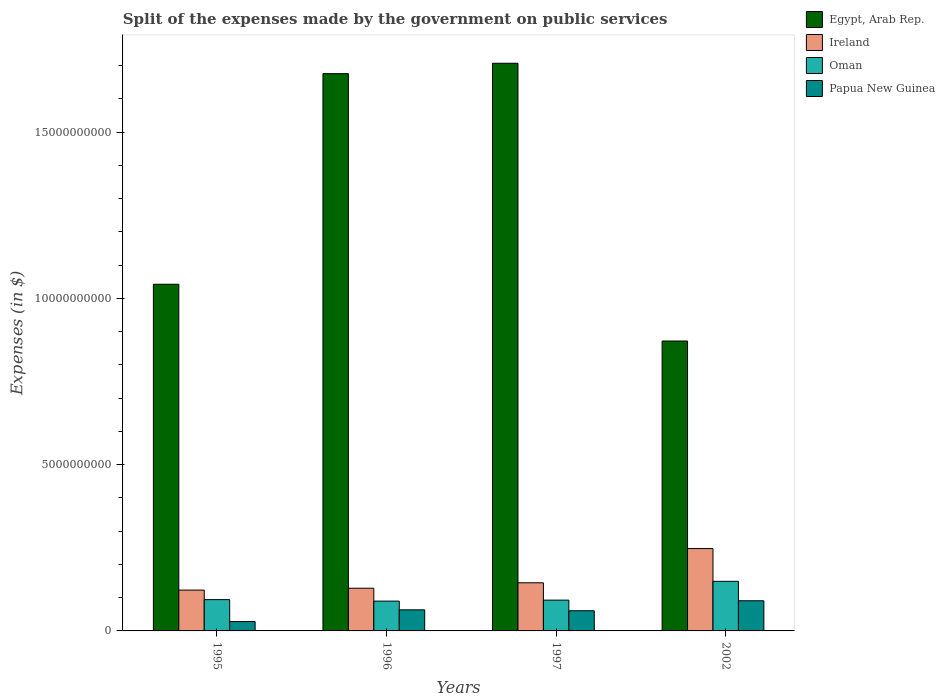How many different coloured bars are there?
Ensure brevity in your answer.  4. What is the label of the 4th group of bars from the left?
Offer a terse response. 2002. What is the expenses made by the government on public services in Ireland in 2002?
Your answer should be very brief. 2.48e+09. Across all years, what is the maximum expenses made by the government on public services in Egypt, Arab Rep.?
Make the answer very short. 1.71e+1. Across all years, what is the minimum expenses made by the government on public services in Ireland?
Provide a succinct answer. 1.23e+09. What is the total expenses made by the government on public services in Egypt, Arab Rep. in the graph?
Your response must be concise. 5.30e+1. What is the difference between the expenses made by the government on public services in Papua New Guinea in 1995 and that in 2002?
Ensure brevity in your answer.  -6.25e+08. What is the difference between the expenses made by the government on public services in Ireland in 1997 and the expenses made by the government on public services in Papua New Guinea in 2002?
Ensure brevity in your answer.  5.40e+08. What is the average expenses made by the government on public services in Oman per year?
Provide a succinct answer. 1.06e+09. In the year 1997, what is the difference between the expenses made by the government on public services in Ireland and expenses made by the government on public services in Egypt, Arab Rep.?
Provide a short and direct response. -1.56e+1. In how many years, is the expenses made by the government on public services in Oman greater than 12000000000 $?
Make the answer very short. 0. What is the ratio of the expenses made by the government on public services in Egypt, Arab Rep. in 1995 to that in 2002?
Offer a very short reply. 1.2. Is the difference between the expenses made by the government on public services in Ireland in 1995 and 1996 greater than the difference between the expenses made by the government on public services in Egypt, Arab Rep. in 1995 and 1996?
Your answer should be very brief. Yes. What is the difference between the highest and the second highest expenses made by the government on public services in Egypt, Arab Rep.?
Offer a terse response. 3.12e+08. What is the difference between the highest and the lowest expenses made by the government on public services in Ireland?
Ensure brevity in your answer.  1.25e+09. Is it the case that in every year, the sum of the expenses made by the government on public services in Papua New Guinea and expenses made by the government on public services in Egypt, Arab Rep. is greater than the sum of expenses made by the government on public services in Ireland and expenses made by the government on public services in Oman?
Ensure brevity in your answer.  No. What does the 4th bar from the left in 2002 represents?
Ensure brevity in your answer.  Papua New Guinea. What does the 1st bar from the right in 1996 represents?
Keep it short and to the point. Papua New Guinea. Is it the case that in every year, the sum of the expenses made by the government on public services in Papua New Guinea and expenses made by the government on public services in Oman is greater than the expenses made by the government on public services in Egypt, Arab Rep.?
Make the answer very short. No. Are the values on the major ticks of Y-axis written in scientific E-notation?
Give a very brief answer. No. Does the graph contain grids?
Ensure brevity in your answer.  No. Where does the legend appear in the graph?
Provide a short and direct response. Top right. How many legend labels are there?
Your answer should be very brief. 4. How are the legend labels stacked?
Your answer should be compact. Vertical. What is the title of the graph?
Ensure brevity in your answer.  Split of the expenses made by the government on public services. Does "Middle East & North Africa (developing only)" appear as one of the legend labels in the graph?
Your answer should be compact. No. What is the label or title of the X-axis?
Your response must be concise. Years. What is the label or title of the Y-axis?
Your response must be concise. Expenses (in $). What is the Expenses (in $) in Egypt, Arab Rep. in 1995?
Give a very brief answer. 1.04e+1. What is the Expenses (in $) of Ireland in 1995?
Your answer should be very brief. 1.23e+09. What is the Expenses (in $) in Oman in 1995?
Ensure brevity in your answer.  9.41e+08. What is the Expenses (in $) in Papua New Guinea in 1995?
Provide a succinct answer. 2.82e+08. What is the Expenses (in $) of Egypt, Arab Rep. in 1996?
Offer a very short reply. 1.68e+1. What is the Expenses (in $) in Ireland in 1996?
Keep it short and to the point. 1.28e+09. What is the Expenses (in $) in Oman in 1996?
Provide a short and direct response. 8.96e+08. What is the Expenses (in $) of Papua New Guinea in 1996?
Your answer should be compact. 6.34e+08. What is the Expenses (in $) of Egypt, Arab Rep. in 1997?
Your answer should be very brief. 1.71e+1. What is the Expenses (in $) in Ireland in 1997?
Offer a terse response. 1.45e+09. What is the Expenses (in $) in Oman in 1997?
Make the answer very short. 9.26e+08. What is the Expenses (in $) of Papua New Guinea in 1997?
Provide a short and direct response. 6.06e+08. What is the Expenses (in $) in Egypt, Arab Rep. in 2002?
Offer a terse response. 8.72e+09. What is the Expenses (in $) in Ireland in 2002?
Offer a very short reply. 2.48e+09. What is the Expenses (in $) of Oman in 2002?
Offer a terse response. 1.49e+09. What is the Expenses (in $) of Papua New Guinea in 2002?
Offer a terse response. 9.07e+08. Across all years, what is the maximum Expenses (in $) in Egypt, Arab Rep.?
Offer a very short reply. 1.71e+1. Across all years, what is the maximum Expenses (in $) of Ireland?
Offer a very short reply. 2.48e+09. Across all years, what is the maximum Expenses (in $) of Oman?
Provide a succinct answer. 1.49e+09. Across all years, what is the maximum Expenses (in $) in Papua New Guinea?
Give a very brief answer. 9.07e+08. Across all years, what is the minimum Expenses (in $) of Egypt, Arab Rep.?
Offer a terse response. 8.72e+09. Across all years, what is the minimum Expenses (in $) of Ireland?
Your answer should be compact. 1.23e+09. Across all years, what is the minimum Expenses (in $) in Oman?
Your response must be concise. 8.96e+08. Across all years, what is the minimum Expenses (in $) in Papua New Guinea?
Ensure brevity in your answer.  2.82e+08. What is the total Expenses (in $) in Egypt, Arab Rep. in the graph?
Offer a terse response. 5.30e+1. What is the total Expenses (in $) of Ireland in the graph?
Offer a terse response. 6.44e+09. What is the total Expenses (in $) in Oman in the graph?
Offer a very short reply. 4.25e+09. What is the total Expenses (in $) of Papua New Guinea in the graph?
Provide a succinct answer. 2.43e+09. What is the difference between the Expenses (in $) of Egypt, Arab Rep. in 1995 and that in 1996?
Keep it short and to the point. -6.33e+09. What is the difference between the Expenses (in $) in Ireland in 1995 and that in 1996?
Your response must be concise. -5.60e+07. What is the difference between the Expenses (in $) in Oman in 1995 and that in 1996?
Your answer should be very brief. 4.52e+07. What is the difference between the Expenses (in $) of Papua New Guinea in 1995 and that in 1996?
Ensure brevity in your answer.  -3.52e+08. What is the difference between the Expenses (in $) of Egypt, Arab Rep. in 1995 and that in 1997?
Keep it short and to the point. -6.64e+09. What is the difference between the Expenses (in $) in Ireland in 1995 and that in 1997?
Make the answer very short. -2.19e+08. What is the difference between the Expenses (in $) of Oman in 1995 and that in 1997?
Offer a very short reply. 1.56e+07. What is the difference between the Expenses (in $) of Papua New Guinea in 1995 and that in 1997?
Provide a short and direct response. -3.25e+08. What is the difference between the Expenses (in $) of Egypt, Arab Rep. in 1995 and that in 2002?
Provide a short and direct response. 1.71e+09. What is the difference between the Expenses (in $) in Ireland in 1995 and that in 2002?
Your answer should be compact. -1.25e+09. What is the difference between the Expenses (in $) in Oman in 1995 and that in 2002?
Give a very brief answer. -5.50e+08. What is the difference between the Expenses (in $) in Papua New Guinea in 1995 and that in 2002?
Your answer should be very brief. -6.25e+08. What is the difference between the Expenses (in $) of Egypt, Arab Rep. in 1996 and that in 1997?
Give a very brief answer. -3.12e+08. What is the difference between the Expenses (in $) in Ireland in 1996 and that in 1997?
Provide a succinct answer. -1.63e+08. What is the difference between the Expenses (in $) in Oman in 1996 and that in 1997?
Keep it short and to the point. -2.96e+07. What is the difference between the Expenses (in $) in Papua New Guinea in 1996 and that in 1997?
Provide a succinct answer. 2.76e+07. What is the difference between the Expenses (in $) in Egypt, Arab Rep. in 1996 and that in 2002?
Provide a succinct answer. 8.04e+09. What is the difference between the Expenses (in $) in Ireland in 1996 and that in 2002?
Ensure brevity in your answer.  -1.19e+09. What is the difference between the Expenses (in $) in Oman in 1996 and that in 2002?
Offer a very short reply. -5.95e+08. What is the difference between the Expenses (in $) in Papua New Guinea in 1996 and that in 2002?
Ensure brevity in your answer.  -2.73e+08. What is the difference between the Expenses (in $) of Egypt, Arab Rep. in 1997 and that in 2002?
Provide a short and direct response. 8.35e+09. What is the difference between the Expenses (in $) of Ireland in 1997 and that in 2002?
Keep it short and to the point. -1.03e+09. What is the difference between the Expenses (in $) in Oman in 1997 and that in 2002?
Your answer should be very brief. -5.66e+08. What is the difference between the Expenses (in $) of Papua New Guinea in 1997 and that in 2002?
Keep it short and to the point. -3.00e+08. What is the difference between the Expenses (in $) in Egypt, Arab Rep. in 1995 and the Expenses (in $) in Ireland in 1996?
Make the answer very short. 9.14e+09. What is the difference between the Expenses (in $) of Egypt, Arab Rep. in 1995 and the Expenses (in $) of Oman in 1996?
Make the answer very short. 9.53e+09. What is the difference between the Expenses (in $) of Egypt, Arab Rep. in 1995 and the Expenses (in $) of Papua New Guinea in 1996?
Offer a very short reply. 9.79e+09. What is the difference between the Expenses (in $) in Ireland in 1995 and the Expenses (in $) in Oman in 1996?
Your answer should be very brief. 3.32e+08. What is the difference between the Expenses (in $) of Ireland in 1995 and the Expenses (in $) of Papua New Guinea in 1996?
Make the answer very short. 5.94e+08. What is the difference between the Expenses (in $) of Oman in 1995 and the Expenses (in $) of Papua New Guinea in 1996?
Ensure brevity in your answer.  3.07e+08. What is the difference between the Expenses (in $) in Egypt, Arab Rep. in 1995 and the Expenses (in $) in Ireland in 1997?
Give a very brief answer. 8.98e+09. What is the difference between the Expenses (in $) in Egypt, Arab Rep. in 1995 and the Expenses (in $) in Oman in 1997?
Your answer should be very brief. 9.50e+09. What is the difference between the Expenses (in $) of Egypt, Arab Rep. in 1995 and the Expenses (in $) of Papua New Guinea in 1997?
Give a very brief answer. 9.82e+09. What is the difference between the Expenses (in $) of Ireland in 1995 and the Expenses (in $) of Oman in 1997?
Give a very brief answer. 3.02e+08. What is the difference between the Expenses (in $) of Ireland in 1995 and the Expenses (in $) of Papua New Guinea in 1997?
Give a very brief answer. 6.22e+08. What is the difference between the Expenses (in $) in Oman in 1995 and the Expenses (in $) in Papua New Guinea in 1997?
Provide a succinct answer. 3.35e+08. What is the difference between the Expenses (in $) of Egypt, Arab Rep. in 1995 and the Expenses (in $) of Ireland in 2002?
Provide a short and direct response. 7.95e+09. What is the difference between the Expenses (in $) in Egypt, Arab Rep. in 1995 and the Expenses (in $) in Oman in 2002?
Ensure brevity in your answer.  8.93e+09. What is the difference between the Expenses (in $) of Egypt, Arab Rep. in 1995 and the Expenses (in $) of Papua New Guinea in 2002?
Provide a short and direct response. 9.52e+09. What is the difference between the Expenses (in $) of Ireland in 1995 and the Expenses (in $) of Oman in 2002?
Your response must be concise. -2.64e+08. What is the difference between the Expenses (in $) in Ireland in 1995 and the Expenses (in $) in Papua New Guinea in 2002?
Give a very brief answer. 3.21e+08. What is the difference between the Expenses (in $) in Oman in 1995 and the Expenses (in $) in Papua New Guinea in 2002?
Offer a very short reply. 3.46e+07. What is the difference between the Expenses (in $) of Egypt, Arab Rep. in 1996 and the Expenses (in $) of Ireland in 1997?
Your response must be concise. 1.53e+1. What is the difference between the Expenses (in $) of Egypt, Arab Rep. in 1996 and the Expenses (in $) of Oman in 1997?
Ensure brevity in your answer.  1.58e+1. What is the difference between the Expenses (in $) in Egypt, Arab Rep. in 1996 and the Expenses (in $) in Papua New Guinea in 1997?
Ensure brevity in your answer.  1.61e+1. What is the difference between the Expenses (in $) of Ireland in 1996 and the Expenses (in $) of Oman in 1997?
Ensure brevity in your answer.  3.58e+08. What is the difference between the Expenses (in $) in Ireland in 1996 and the Expenses (in $) in Papua New Guinea in 1997?
Give a very brief answer. 6.78e+08. What is the difference between the Expenses (in $) of Oman in 1996 and the Expenses (in $) of Papua New Guinea in 1997?
Provide a short and direct response. 2.90e+08. What is the difference between the Expenses (in $) in Egypt, Arab Rep. in 1996 and the Expenses (in $) in Ireland in 2002?
Provide a short and direct response. 1.43e+1. What is the difference between the Expenses (in $) of Egypt, Arab Rep. in 1996 and the Expenses (in $) of Oman in 2002?
Provide a short and direct response. 1.53e+1. What is the difference between the Expenses (in $) of Egypt, Arab Rep. in 1996 and the Expenses (in $) of Papua New Guinea in 2002?
Your response must be concise. 1.58e+1. What is the difference between the Expenses (in $) in Ireland in 1996 and the Expenses (in $) in Oman in 2002?
Provide a succinct answer. -2.08e+08. What is the difference between the Expenses (in $) of Ireland in 1996 and the Expenses (in $) of Papua New Guinea in 2002?
Your response must be concise. 3.77e+08. What is the difference between the Expenses (in $) of Oman in 1996 and the Expenses (in $) of Papua New Guinea in 2002?
Provide a succinct answer. -1.06e+07. What is the difference between the Expenses (in $) of Egypt, Arab Rep. in 1997 and the Expenses (in $) of Ireland in 2002?
Your answer should be compact. 1.46e+1. What is the difference between the Expenses (in $) in Egypt, Arab Rep. in 1997 and the Expenses (in $) in Oman in 2002?
Ensure brevity in your answer.  1.56e+1. What is the difference between the Expenses (in $) of Egypt, Arab Rep. in 1997 and the Expenses (in $) of Papua New Guinea in 2002?
Provide a succinct answer. 1.62e+1. What is the difference between the Expenses (in $) in Ireland in 1997 and the Expenses (in $) in Oman in 2002?
Provide a short and direct response. -4.44e+07. What is the difference between the Expenses (in $) in Ireland in 1997 and the Expenses (in $) in Papua New Guinea in 2002?
Provide a succinct answer. 5.40e+08. What is the difference between the Expenses (in $) in Oman in 1997 and the Expenses (in $) in Papua New Guinea in 2002?
Provide a short and direct response. 1.90e+07. What is the average Expenses (in $) in Egypt, Arab Rep. per year?
Ensure brevity in your answer.  1.32e+1. What is the average Expenses (in $) in Ireland per year?
Provide a succinct answer. 1.61e+09. What is the average Expenses (in $) of Oman per year?
Provide a succinct answer. 1.06e+09. What is the average Expenses (in $) of Papua New Guinea per year?
Provide a succinct answer. 6.07e+08. In the year 1995, what is the difference between the Expenses (in $) in Egypt, Arab Rep. and Expenses (in $) in Ireland?
Give a very brief answer. 9.20e+09. In the year 1995, what is the difference between the Expenses (in $) in Egypt, Arab Rep. and Expenses (in $) in Oman?
Your answer should be very brief. 9.48e+09. In the year 1995, what is the difference between the Expenses (in $) of Egypt, Arab Rep. and Expenses (in $) of Papua New Guinea?
Your answer should be very brief. 1.01e+1. In the year 1995, what is the difference between the Expenses (in $) in Ireland and Expenses (in $) in Oman?
Ensure brevity in your answer.  2.87e+08. In the year 1995, what is the difference between the Expenses (in $) of Ireland and Expenses (in $) of Papua New Guinea?
Provide a succinct answer. 9.46e+08. In the year 1995, what is the difference between the Expenses (in $) in Oman and Expenses (in $) in Papua New Guinea?
Ensure brevity in your answer.  6.60e+08. In the year 1996, what is the difference between the Expenses (in $) of Egypt, Arab Rep. and Expenses (in $) of Ireland?
Keep it short and to the point. 1.55e+1. In the year 1996, what is the difference between the Expenses (in $) in Egypt, Arab Rep. and Expenses (in $) in Oman?
Keep it short and to the point. 1.59e+1. In the year 1996, what is the difference between the Expenses (in $) in Egypt, Arab Rep. and Expenses (in $) in Papua New Guinea?
Offer a terse response. 1.61e+1. In the year 1996, what is the difference between the Expenses (in $) in Ireland and Expenses (in $) in Oman?
Keep it short and to the point. 3.88e+08. In the year 1996, what is the difference between the Expenses (in $) of Ireland and Expenses (in $) of Papua New Guinea?
Offer a terse response. 6.50e+08. In the year 1996, what is the difference between the Expenses (in $) in Oman and Expenses (in $) in Papua New Guinea?
Offer a terse response. 2.62e+08. In the year 1997, what is the difference between the Expenses (in $) in Egypt, Arab Rep. and Expenses (in $) in Ireland?
Offer a very short reply. 1.56e+1. In the year 1997, what is the difference between the Expenses (in $) in Egypt, Arab Rep. and Expenses (in $) in Oman?
Offer a very short reply. 1.61e+1. In the year 1997, what is the difference between the Expenses (in $) of Egypt, Arab Rep. and Expenses (in $) of Papua New Guinea?
Provide a short and direct response. 1.65e+1. In the year 1997, what is the difference between the Expenses (in $) of Ireland and Expenses (in $) of Oman?
Your response must be concise. 5.21e+08. In the year 1997, what is the difference between the Expenses (in $) of Ireland and Expenses (in $) of Papua New Guinea?
Offer a terse response. 8.41e+08. In the year 1997, what is the difference between the Expenses (in $) in Oman and Expenses (in $) in Papua New Guinea?
Offer a very short reply. 3.19e+08. In the year 2002, what is the difference between the Expenses (in $) in Egypt, Arab Rep. and Expenses (in $) in Ireland?
Make the answer very short. 6.24e+09. In the year 2002, what is the difference between the Expenses (in $) of Egypt, Arab Rep. and Expenses (in $) of Oman?
Your response must be concise. 7.23e+09. In the year 2002, what is the difference between the Expenses (in $) in Egypt, Arab Rep. and Expenses (in $) in Papua New Guinea?
Your answer should be compact. 7.81e+09. In the year 2002, what is the difference between the Expenses (in $) in Ireland and Expenses (in $) in Oman?
Give a very brief answer. 9.85e+08. In the year 2002, what is the difference between the Expenses (in $) of Ireland and Expenses (in $) of Papua New Guinea?
Offer a very short reply. 1.57e+09. In the year 2002, what is the difference between the Expenses (in $) in Oman and Expenses (in $) in Papua New Guinea?
Your answer should be compact. 5.85e+08. What is the ratio of the Expenses (in $) of Egypt, Arab Rep. in 1995 to that in 1996?
Make the answer very short. 0.62. What is the ratio of the Expenses (in $) in Ireland in 1995 to that in 1996?
Offer a very short reply. 0.96. What is the ratio of the Expenses (in $) of Oman in 1995 to that in 1996?
Ensure brevity in your answer.  1.05. What is the ratio of the Expenses (in $) in Papua New Guinea in 1995 to that in 1996?
Offer a very short reply. 0.44. What is the ratio of the Expenses (in $) of Egypt, Arab Rep. in 1995 to that in 1997?
Provide a short and direct response. 0.61. What is the ratio of the Expenses (in $) of Ireland in 1995 to that in 1997?
Ensure brevity in your answer.  0.85. What is the ratio of the Expenses (in $) of Oman in 1995 to that in 1997?
Your response must be concise. 1.02. What is the ratio of the Expenses (in $) of Papua New Guinea in 1995 to that in 1997?
Provide a short and direct response. 0.46. What is the ratio of the Expenses (in $) of Egypt, Arab Rep. in 1995 to that in 2002?
Provide a short and direct response. 1.2. What is the ratio of the Expenses (in $) of Ireland in 1995 to that in 2002?
Give a very brief answer. 0.5. What is the ratio of the Expenses (in $) in Oman in 1995 to that in 2002?
Give a very brief answer. 0.63. What is the ratio of the Expenses (in $) of Papua New Guinea in 1995 to that in 2002?
Offer a terse response. 0.31. What is the ratio of the Expenses (in $) of Egypt, Arab Rep. in 1996 to that in 1997?
Provide a short and direct response. 0.98. What is the ratio of the Expenses (in $) of Ireland in 1996 to that in 1997?
Offer a very short reply. 0.89. What is the ratio of the Expenses (in $) of Papua New Guinea in 1996 to that in 1997?
Offer a very short reply. 1.05. What is the ratio of the Expenses (in $) in Egypt, Arab Rep. in 1996 to that in 2002?
Provide a short and direct response. 1.92. What is the ratio of the Expenses (in $) of Ireland in 1996 to that in 2002?
Your answer should be compact. 0.52. What is the ratio of the Expenses (in $) in Oman in 1996 to that in 2002?
Ensure brevity in your answer.  0.6. What is the ratio of the Expenses (in $) of Papua New Guinea in 1996 to that in 2002?
Give a very brief answer. 0.7. What is the ratio of the Expenses (in $) in Egypt, Arab Rep. in 1997 to that in 2002?
Your answer should be compact. 1.96. What is the ratio of the Expenses (in $) of Ireland in 1997 to that in 2002?
Keep it short and to the point. 0.58. What is the ratio of the Expenses (in $) of Oman in 1997 to that in 2002?
Your answer should be compact. 0.62. What is the ratio of the Expenses (in $) of Papua New Guinea in 1997 to that in 2002?
Your answer should be very brief. 0.67. What is the difference between the highest and the second highest Expenses (in $) in Egypt, Arab Rep.?
Provide a short and direct response. 3.12e+08. What is the difference between the highest and the second highest Expenses (in $) in Ireland?
Keep it short and to the point. 1.03e+09. What is the difference between the highest and the second highest Expenses (in $) in Oman?
Your answer should be very brief. 5.50e+08. What is the difference between the highest and the second highest Expenses (in $) in Papua New Guinea?
Offer a terse response. 2.73e+08. What is the difference between the highest and the lowest Expenses (in $) in Egypt, Arab Rep.?
Keep it short and to the point. 8.35e+09. What is the difference between the highest and the lowest Expenses (in $) of Ireland?
Keep it short and to the point. 1.25e+09. What is the difference between the highest and the lowest Expenses (in $) in Oman?
Give a very brief answer. 5.95e+08. What is the difference between the highest and the lowest Expenses (in $) in Papua New Guinea?
Keep it short and to the point. 6.25e+08. 